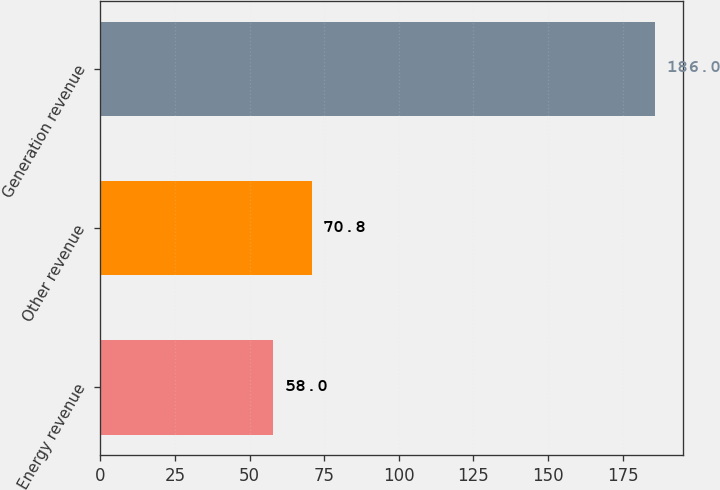<chart> <loc_0><loc_0><loc_500><loc_500><bar_chart><fcel>Energy revenue<fcel>Other revenue<fcel>Generation revenue<nl><fcel>58<fcel>70.8<fcel>186<nl></chart> 